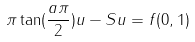Convert formula to latex. <formula><loc_0><loc_0><loc_500><loc_500>\pi \tan ( \frac { a \pi } 2 ) u - S u = f ( 0 , 1 )</formula> 